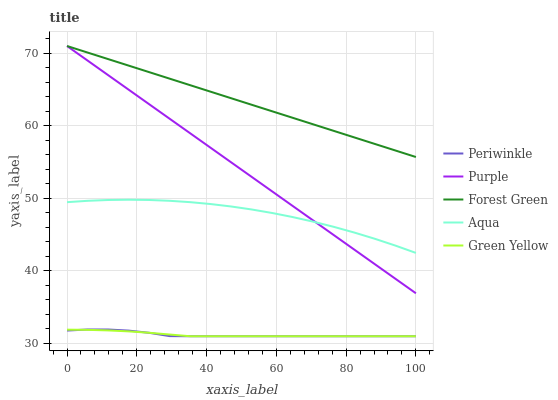Does Periwinkle have the minimum area under the curve?
Answer yes or no. Yes. Does Forest Green have the maximum area under the curve?
Answer yes or no. Yes. Does Aqua have the minimum area under the curve?
Answer yes or no. No. Does Aqua have the maximum area under the curve?
Answer yes or no. No. Is Forest Green the smoothest?
Answer yes or no. Yes. Is Aqua the roughest?
Answer yes or no. Yes. Is Aqua the smoothest?
Answer yes or no. No. Is Forest Green the roughest?
Answer yes or no. No. Does Green Yellow have the lowest value?
Answer yes or no. Yes. Does Aqua have the lowest value?
Answer yes or no. No. Does Forest Green have the highest value?
Answer yes or no. Yes. Does Aqua have the highest value?
Answer yes or no. No. Is Green Yellow less than Forest Green?
Answer yes or no. Yes. Is Purple greater than Periwinkle?
Answer yes or no. Yes. Does Green Yellow intersect Periwinkle?
Answer yes or no. Yes. Is Green Yellow less than Periwinkle?
Answer yes or no. No. Is Green Yellow greater than Periwinkle?
Answer yes or no. No. Does Green Yellow intersect Forest Green?
Answer yes or no. No. 